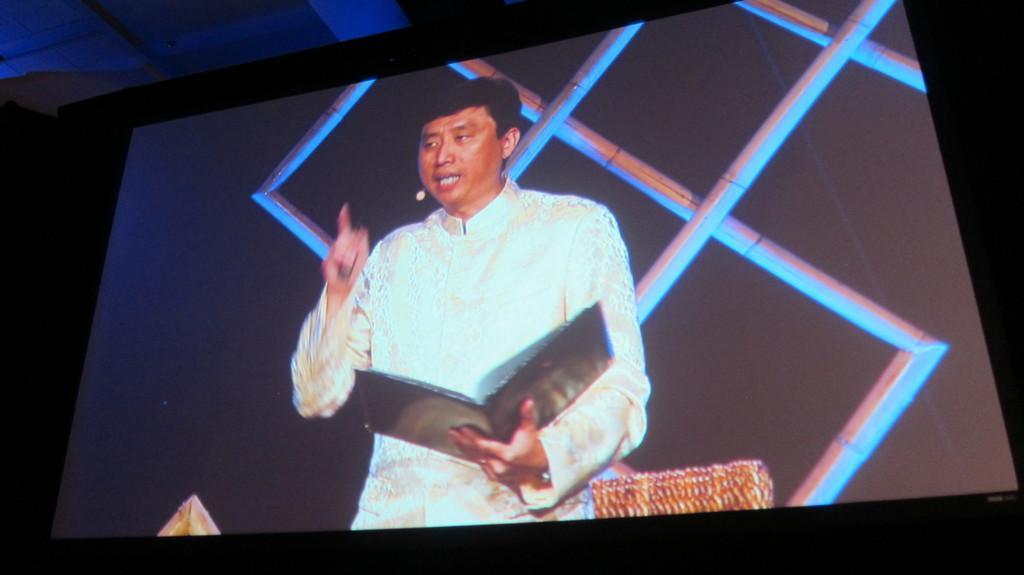In one or two sentences, can you explain what this image depicts? In the image in the center we can see one screen. In the screen,we can see one person standing and holding book. In the background there is a wall and few other objects. 